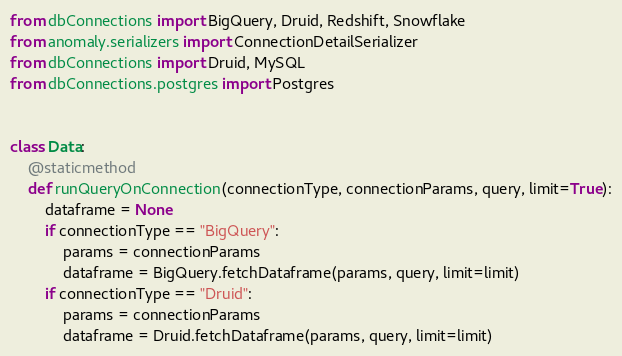<code> <loc_0><loc_0><loc_500><loc_500><_Python_>from dbConnections import BigQuery, Druid, Redshift, Snowflake
from anomaly.serializers import ConnectionDetailSerializer
from dbConnections import Druid, MySQL
from dbConnections.postgres import Postgres


class Data:
    @staticmethod
    def runQueryOnConnection(connectionType, connectionParams, query, limit=True):
        dataframe = None
        if connectionType == "BigQuery":
            params = connectionParams
            dataframe = BigQuery.fetchDataframe(params, query, limit=limit)
        if connectionType == "Druid":
            params = connectionParams
            dataframe = Druid.fetchDataframe(params, query, limit=limit)</code> 